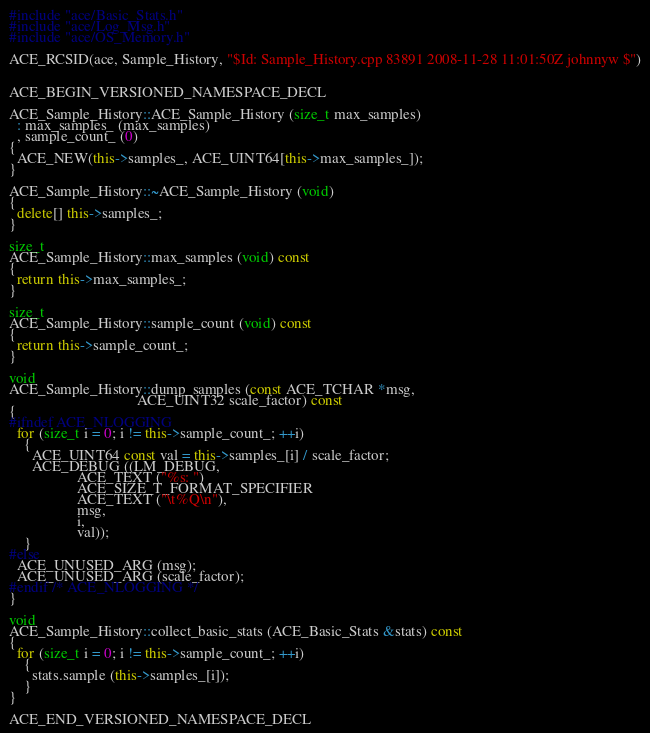<code> <loc_0><loc_0><loc_500><loc_500><_C++_>
#include "ace/Basic_Stats.h"
#include "ace/Log_Msg.h"
#include "ace/OS_Memory.h"

ACE_RCSID(ace, Sample_History, "$Id: Sample_History.cpp 83891 2008-11-28 11:01:50Z johnnyw $")


ACE_BEGIN_VERSIONED_NAMESPACE_DECL

ACE_Sample_History::ACE_Sample_History (size_t max_samples)
  : max_samples_ (max_samples)
  , sample_count_ (0)
{
  ACE_NEW(this->samples_, ACE_UINT64[this->max_samples_]);
}

ACE_Sample_History::~ACE_Sample_History (void)
{
  delete[] this->samples_;
}

size_t
ACE_Sample_History::max_samples (void) const
{
  return this->max_samples_;
}

size_t
ACE_Sample_History::sample_count (void) const
{
  return this->sample_count_;
}

void
ACE_Sample_History::dump_samples (const ACE_TCHAR *msg,
                                  ACE_UINT32 scale_factor) const
{
#ifndef ACE_NLOGGING
  for (size_t i = 0; i != this->sample_count_; ++i)
    {
      ACE_UINT64 const val = this->samples_[i] / scale_factor;
      ACE_DEBUG ((LM_DEBUG,
                  ACE_TEXT ("%s: ")
                  ACE_SIZE_T_FORMAT_SPECIFIER
                  ACE_TEXT ("\t%Q\n"),
                  msg,
                  i,
                  val));
    }
#else
  ACE_UNUSED_ARG (msg);
  ACE_UNUSED_ARG (scale_factor);
#endif /* ACE_NLOGGING */
}

void
ACE_Sample_History::collect_basic_stats (ACE_Basic_Stats &stats) const
{
  for (size_t i = 0; i != this->sample_count_; ++i)
    {
      stats.sample (this->samples_[i]);
    }
}

ACE_END_VERSIONED_NAMESPACE_DECL
</code> 